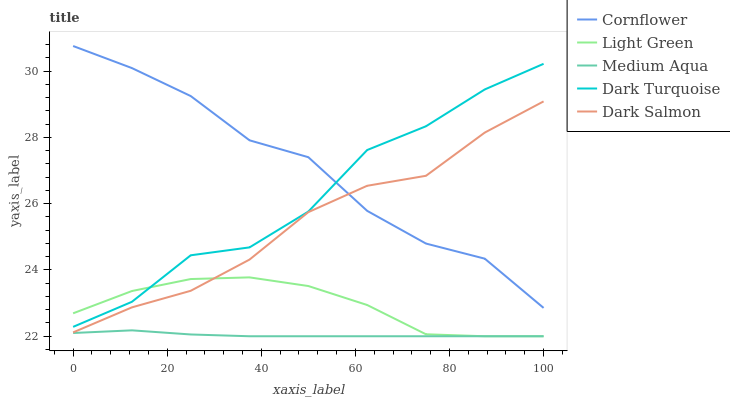Does Dark Salmon have the minimum area under the curve?
Answer yes or no. No. Does Dark Salmon have the maximum area under the curve?
Answer yes or no. No. Is Dark Salmon the smoothest?
Answer yes or no. No. Is Dark Salmon the roughest?
Answer yes or no. No. Does Dark Salmon have the lowest value?
Answer yes or no. No. Does Dark Salmon have the highest value?
Answer yes or no. No. Is Dark Salmon less than Dark Turquoise?
Answer yes or no. Yes. Is Dark Salmon greater than Medium Aqua?
Answer yes or no. Yes. Does Dark Salmon intersect Dark Turquoise?
Answer yes or no. No. 